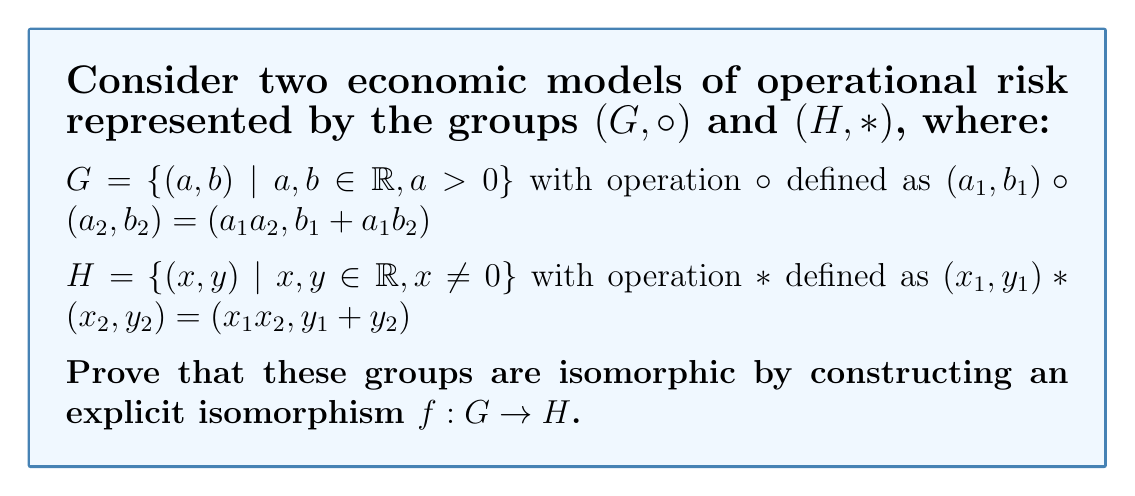What is the answer to this math problem? To prove that the groups $(G, \circ)$ and $(H, *)$ are isomorphic, we need to find a bijective function $f: G \to H$ that preserves the group operation. Let's approach this step-by-step:

1) First, let's propose a function $f: G \to H$ defined as:

   $f(a, b) = (\ln(a), b)$ for $(a, b) \in G$

2) We need to prove that $f$ is bijective:
   - Injective: If $f(a_1, b_1) = f(a_2, b_2)$, then $(\ln(a_1), b_1) = (\ln(a_2), b_2)$, which implies $a_1 = a_2$ and $b_1 = b_2$. Thus, $f$ is injective.
   - Surjective: For any $(x, y) \in H$, we can find $(e^x, y) \in G$ such that $f(e^x, y) = (x, y)$. Thus, $f$ is surjective.

3) Now, we need to show that $f$ preserves the group operation, i.e., $f((a_1, b_1) \circ (a_2, b_2)) = f(a_1, b_1) * f(a_2, b_2)$ for all $(a_1, b_1), (a_2, b_2) \in G$:

   LHS: $f((a_1, b_1) \circ (a_2, b_2)) = f(a_1a_2, b_1 + a_1b_2) = (\ln(a_1a_2), b_1 + a_1b_2)$

   RHS: $f(a_1, b_1) * f(a_2, b_2) = (\ln(a_1), b_1) * (\ln(a_2), b_2) = (\ln(a_1) + \ln(a_2), b_1 + b_2)$

4) Using the properties of logarithms, we know that $\ln(a_1a_2) = \ln(a_1) + \ln(a_2)$. However, we still need to show that $a_1b_2 = b_2$ for the second component to match.

5) This is where the economic interpretation comes in. In the context of operational risk models, $a_1$ can be interpreted as a risk multiplier, which should be 1 in the additive model of $H$. This implies that we need to add a constraint to our isomorphism.

6) Let's modify our isomorphism to $f(a, b) = (\ln(a), ab)$. Now let's verify:

   LHS: $f((a_1, b_1) \circ (a_2, b_2)) = f(a_1a_2, b_1 + a_1b_2) = (\ln(a_1a_2), (a_1a_2)(b_1 + a_1b_2))$

   RHS: $f(a_1, b_1) * f(a_2, b_2) = (\ln(a_1), a_1b_1) * (\ln(a_2), a_2b_2) = (\ln(a_1) + \ln(a_2), a_1b_1 + a_2b_2)$

7) Now, $\ln(a_1a_2) = \ln(a_1) + \ln(a_2)$, and $(a_1a_2)(b_1 + a_1b_2) = a_1a_2b_1 + a_1a_2a_1b_2 = a_1b_1 + a_2b_2$

Therefore, the modified function $f(a, b) = (\ln(a), ab)$ is an isomorphism between $(G, \circ)$ and $(H, *)$.
Answer: The isomorphism between the groups $(G, \circ)$ and $(H, *)$ is given by the function $f: G \to H$ defined as:

$f(a, b) = (\ln(a), ab)$ for $(a, b) \in G$

This function is bijective and preserves the group operation, thus proving that the two groups are isomorphic. 